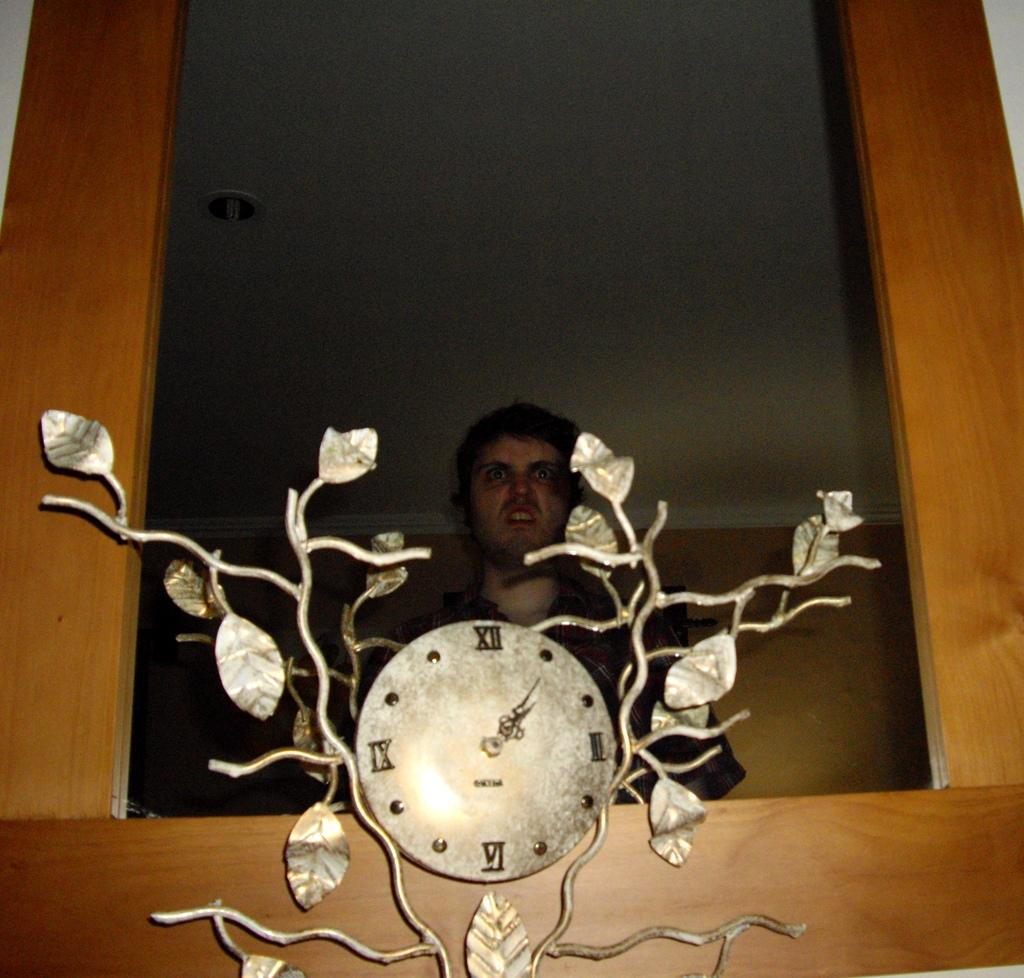<image>
Summarize the visual content of the image. Man looking disgusted standing behind a clock with the hands at 1. 